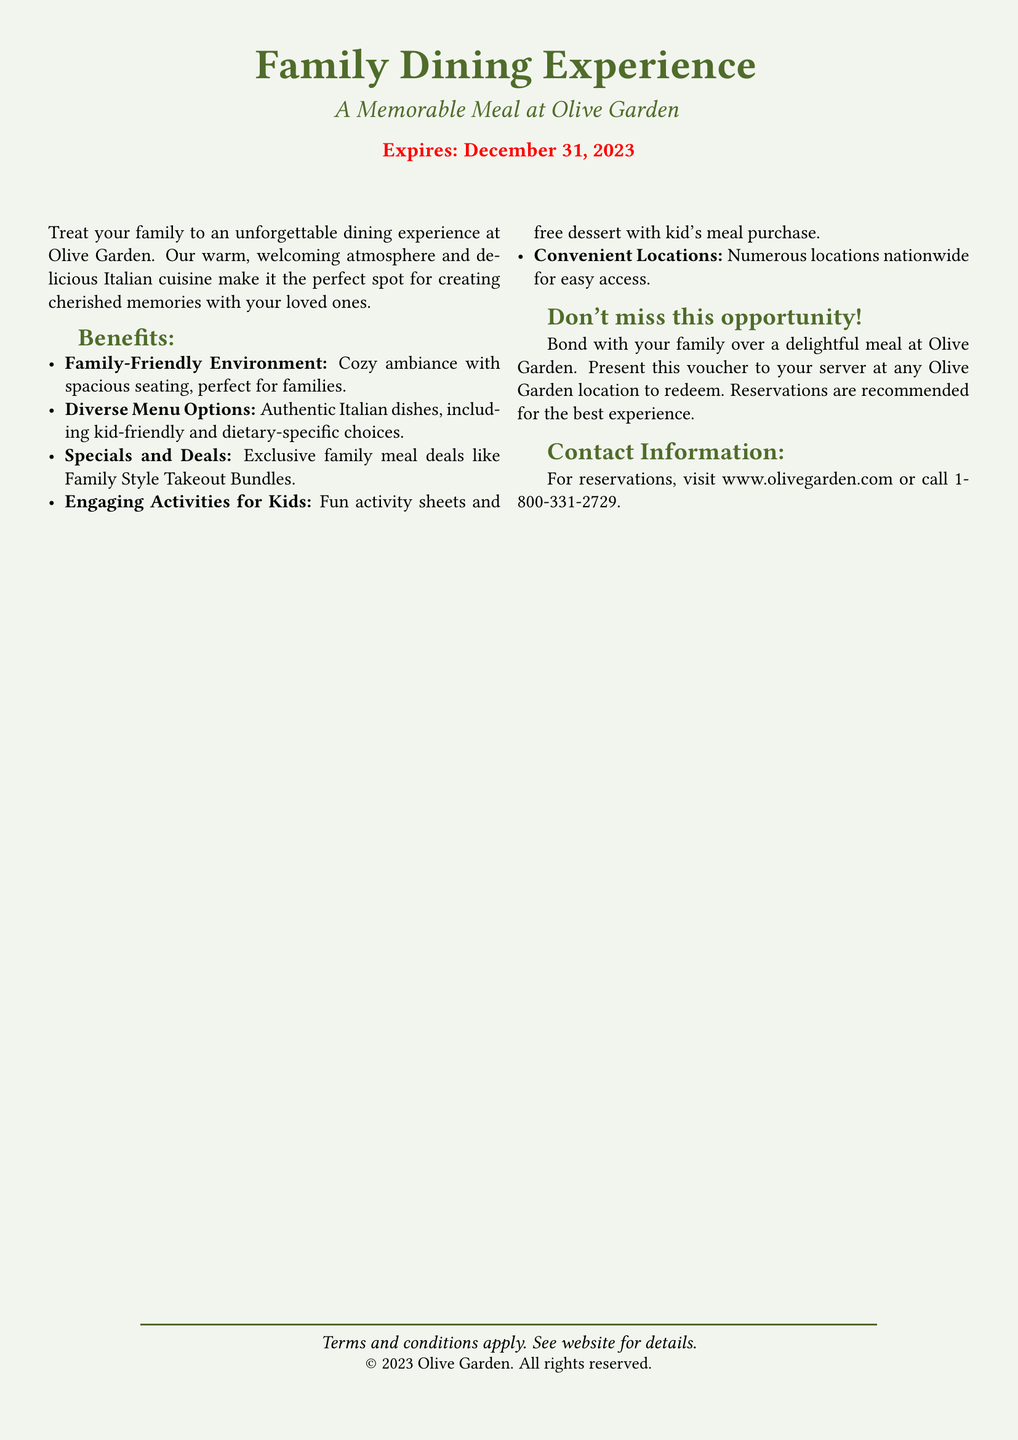What is the name of the restaurant? The restaurant highlighted in the document is Olive Garden.
Answer: Olive Garden What is the expiration date of the voucher? The document specifies the voucher expires on December 31, 2023.
Answer: December 31, 2023 What type of cuisine does Olive Garden offer? The document describes the cuisine offered as authentic Italian dishes.
Answer: Italian What benefit relates to children? The document mentions engaging activities for kids, including fun activity sheets.
Answer: Activities for Kids Where can you find more information or make reservations? The document states to visit www.olivegarden.com or call 1-800-331-2729 for reservations.
Answer: www.olivegarden.com What is one feature of the dining environment? The document highlights a cozy ambiance with spacious seating as a feature.
Answer: Cozy ambiance What type of meal deals are available? The document references exclusive family meal deals like Family Style Takeout Bundles.
Answer: Family Style Takeout Bundles What is recommended for the best experience? The document recommends reservations for the best experience at the restaurant.
Answer: Reservations 